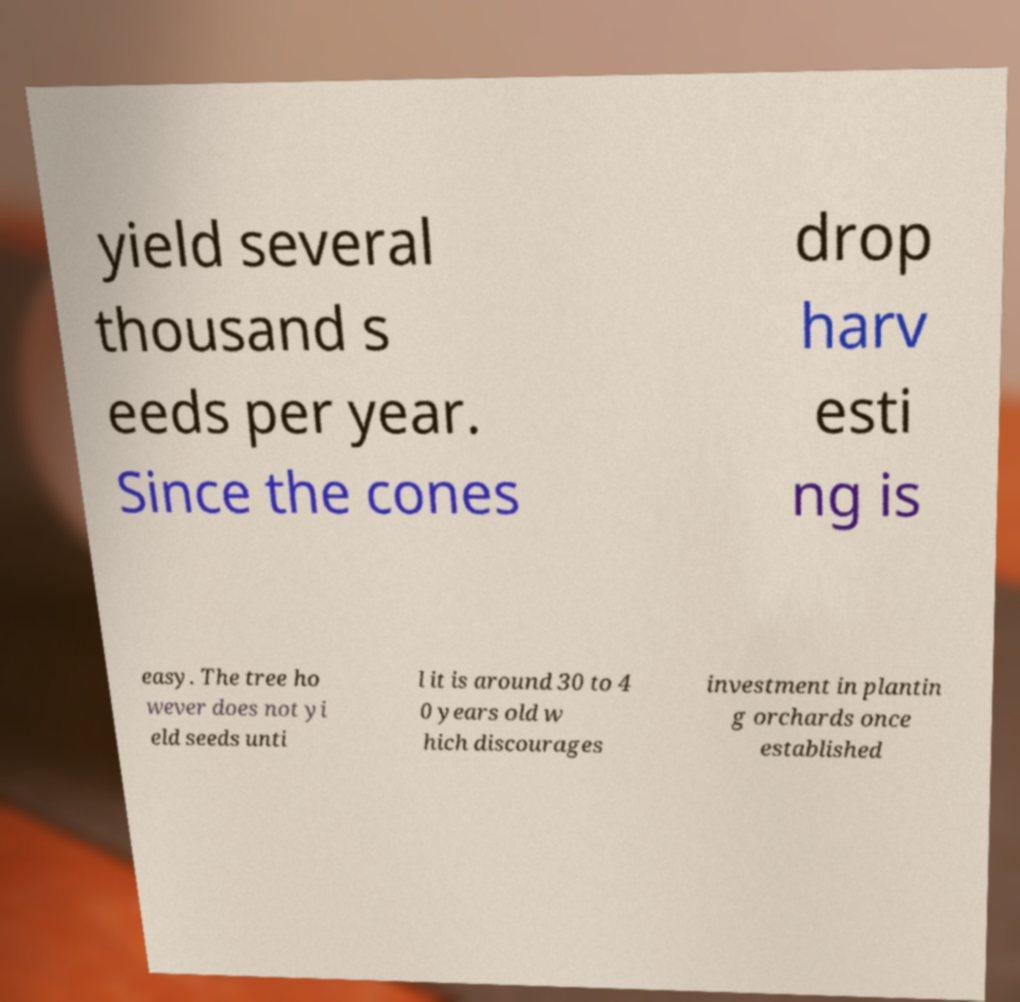There's text embedded in this image that I need extracted. Can you transcribe it verbatim? yield several thousand s eeds per year. Since the cones drop harv esti ng is easy. The tree ho wever does not yi eld seeds unti l it is around 30 to 4 0 years old w hich discourages investment in plantin g orchards once established 